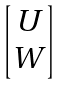<formula> <loc_0><loc_0><loc_500><loc_500>\begin{bmatrix} U \\ W \end{bmatrix}</formula> 